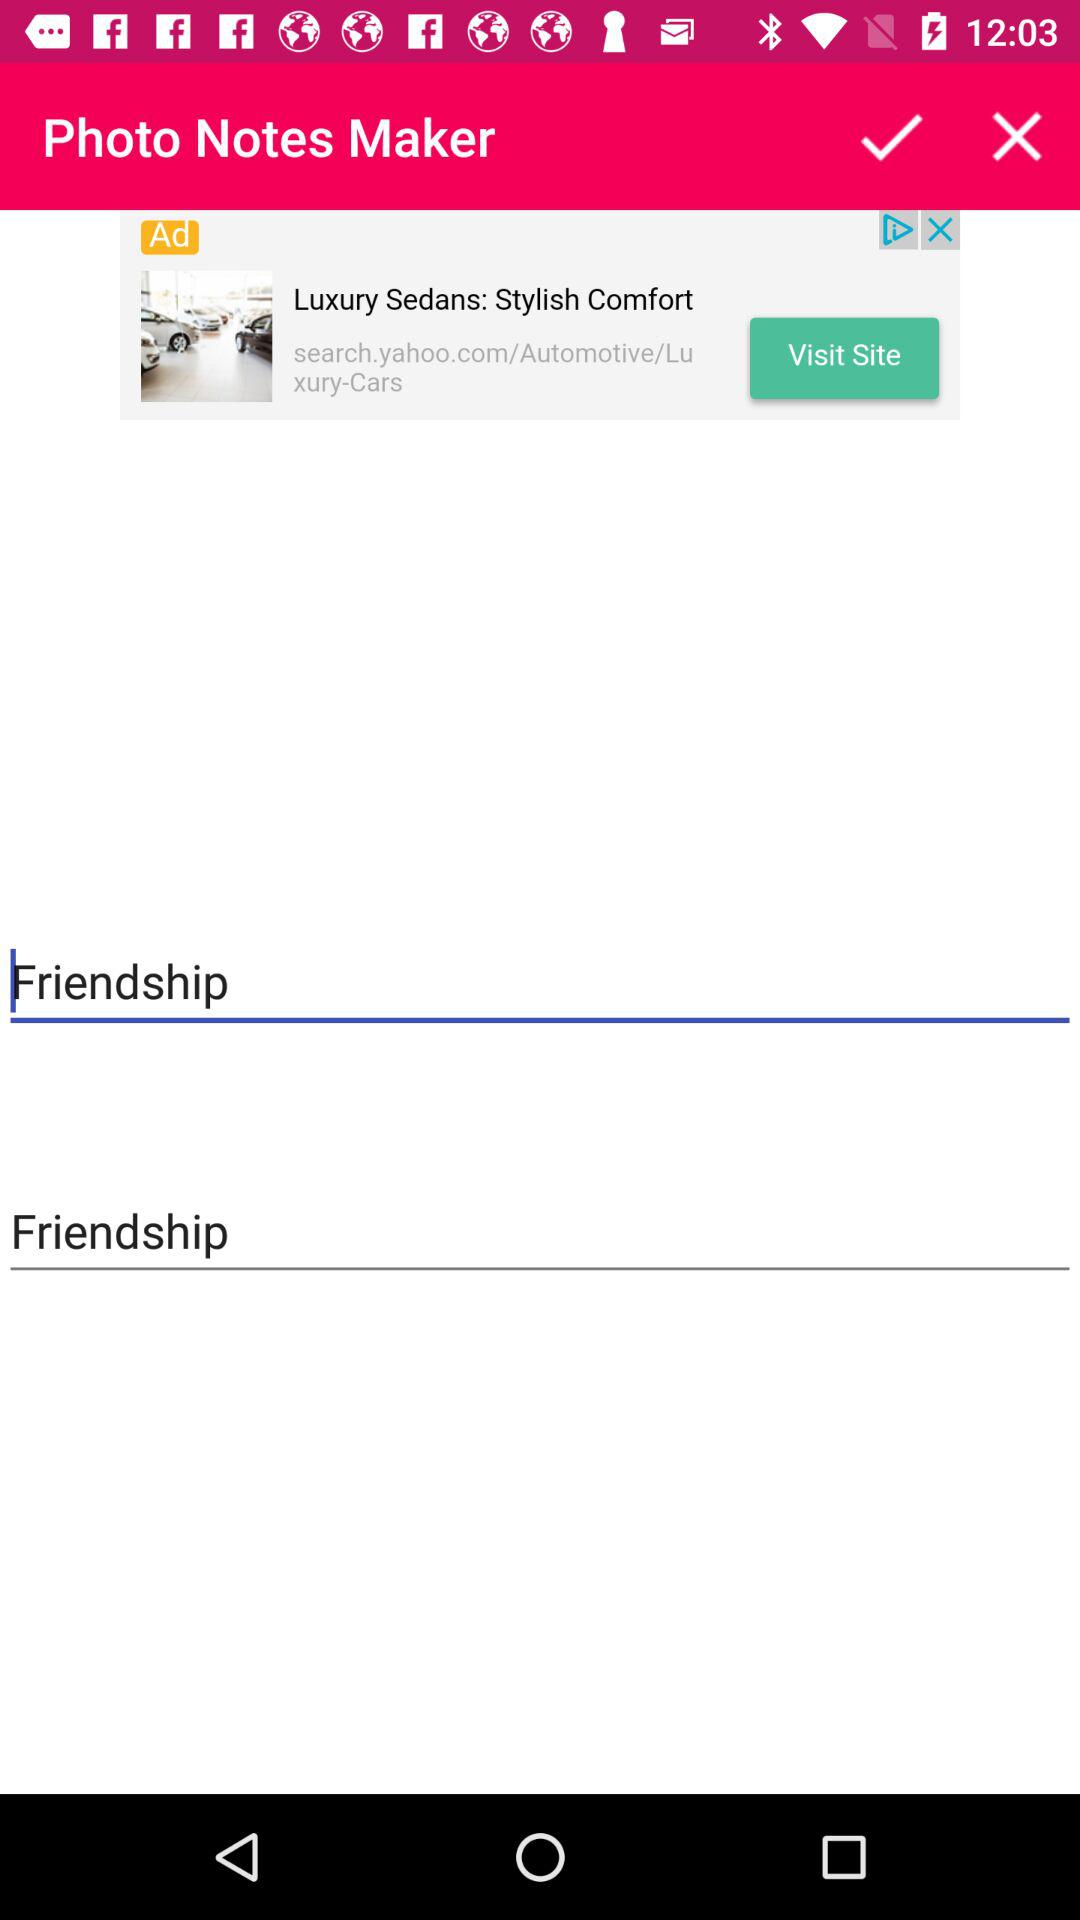What is the name of the application? The name of the application is "Photo Notes Maker". 